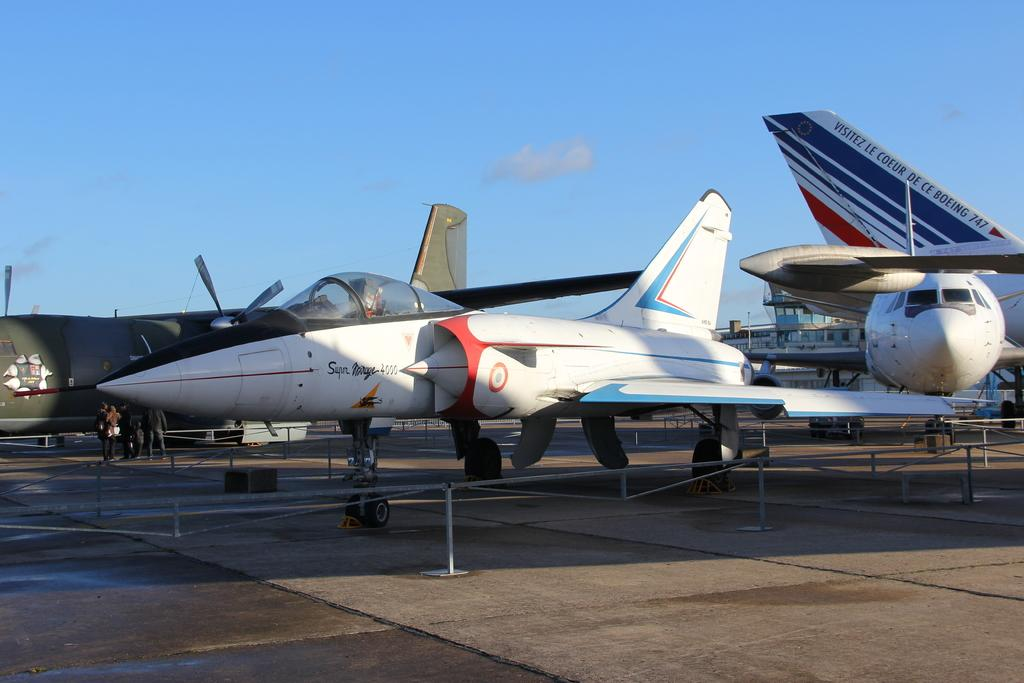Provide a one-sentence caption for the provided image. the super mirage 4000 plane is sitting with other planes behind a barrier. 